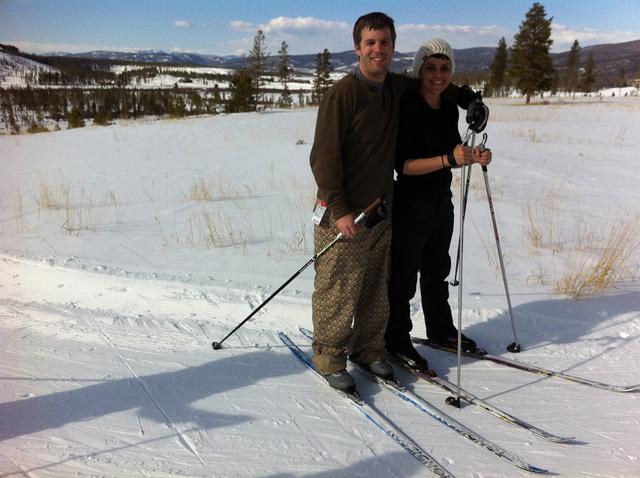What is cast?
Be succinct. Shadow. What do they have in their hand's?
Keep it brief. Ski poles. Is the man dressed warmly?
Short answer required. Yes. Is the skier on fresh powder?
Short answer required. No. Does it look like these people are a couple??
Answer briefly. Yes. 